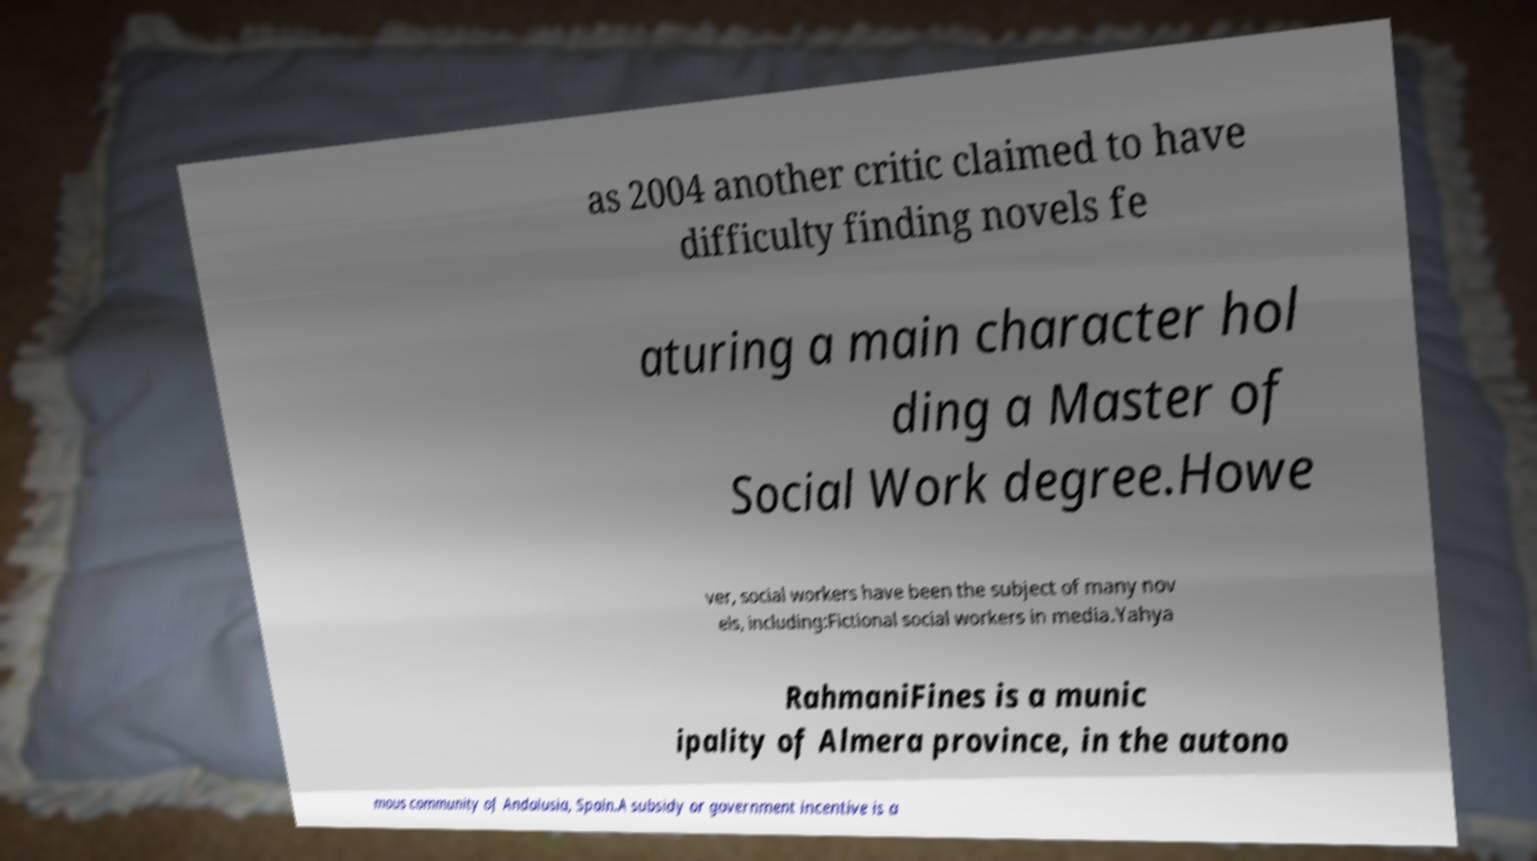Please read and relay the text visible in this image. What does it say? as 2004 another critic claimed to have difficulty finding novels fe aturing a main character hol ding a Master of Social Work degree.Howe ver, social workers have been the subject of many nov els, including:Fictional social workers in media.Yahya RahmaniFines is a munic ipality of Almera province, in the autono mous community of Andalusia, Spain.A subsidy or government incentive is a 